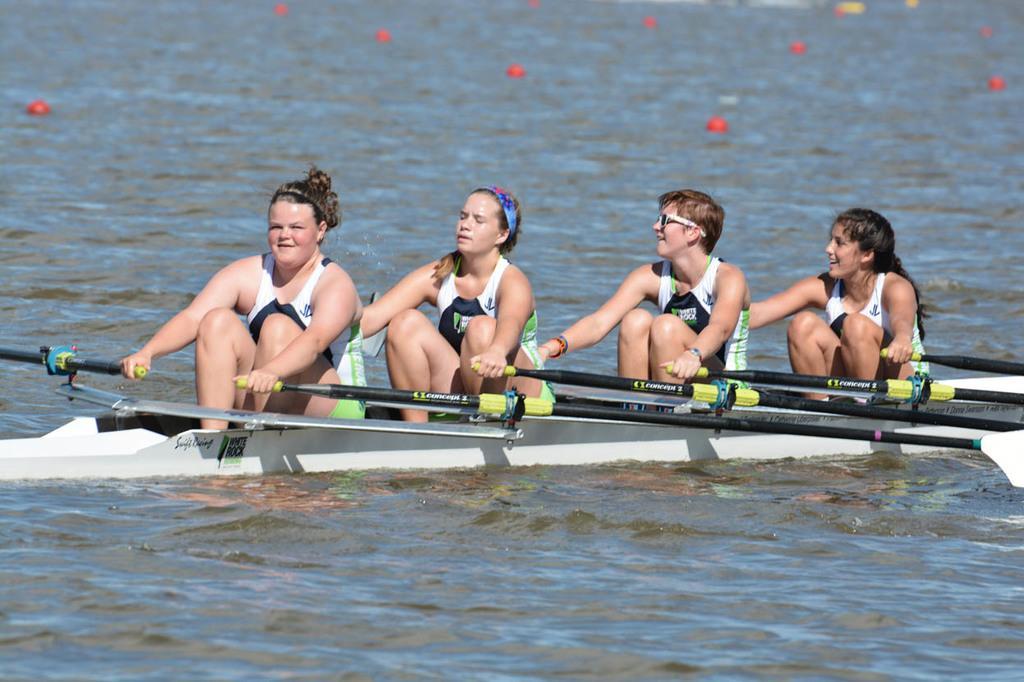Can you describe this image briefly? In this image I see 3 women and a man who are on the boat and all of them are holding paddles in their hands and I see the water and I see red color things on the water. 